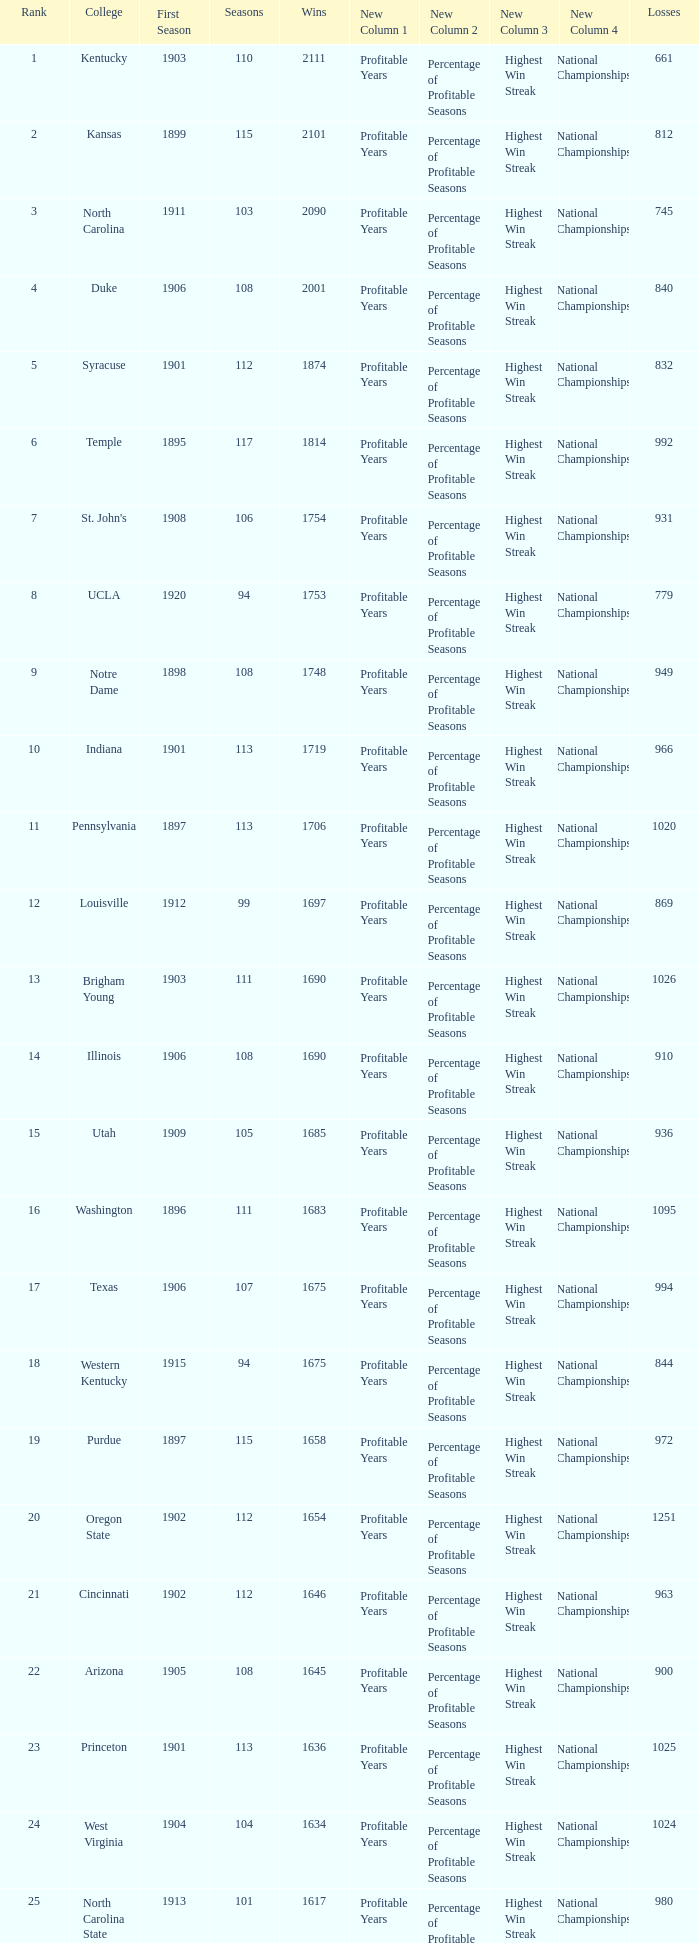What is the total of First Season games with 1537 Wins and a Season greater than 109? None. 